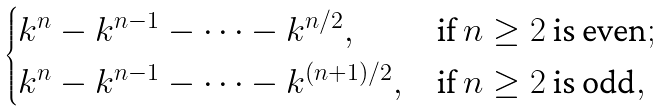Convert formula to latex. <formula><loc_0><loc_0><loc_500><loc_500>\begin{cases} k ^ { n } - k ^ { n - 1 } - \cdots - k ^ { n / 2 } , & \text {if $n \geq 2$ is even} ; \\ k ^ { n } - k ^ { n - 1 } - \cdots - k ^ { ( n + 1 ) / 2 } , & \text {if $n \geq 2$ is odd} , \end{cases}</formula> 